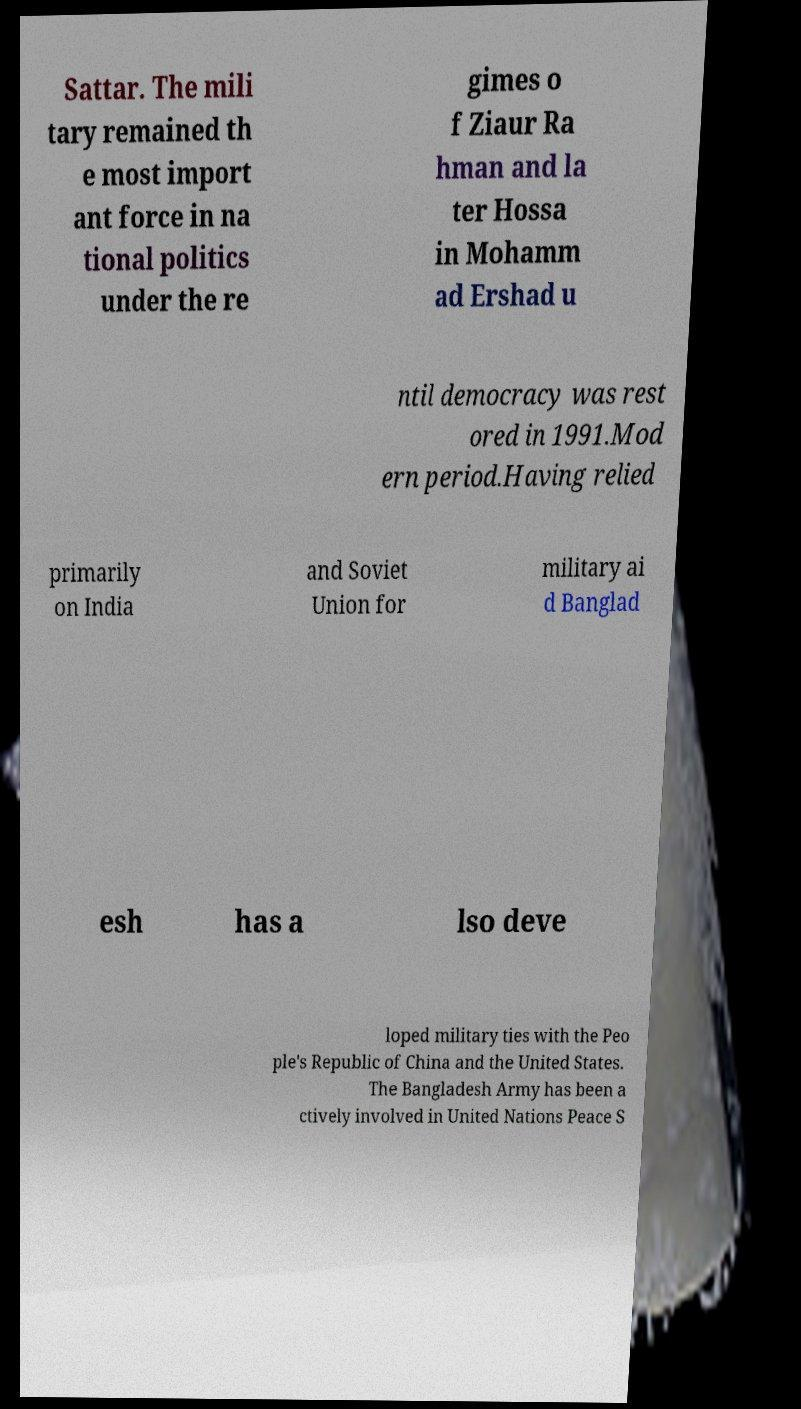There's text embedded in this image that I need extracted. Can you transcribe it verbatim? Sattar. The mili tary remained th e most import ant force in na tional politics under the re gimes o f Ziaur Ra hman and la ter Hossa in Mohamm ad Ershad u ntil democracy was rest ored in 1991.Mod ern period.Having relied primarily on India and Soviet Union for military ai d Banglad esh has a lso deve loped military ties with the Peo ple's Republic of China and the United States. The Bangladesh Army has been a ctively involved in United Nations Peace S 